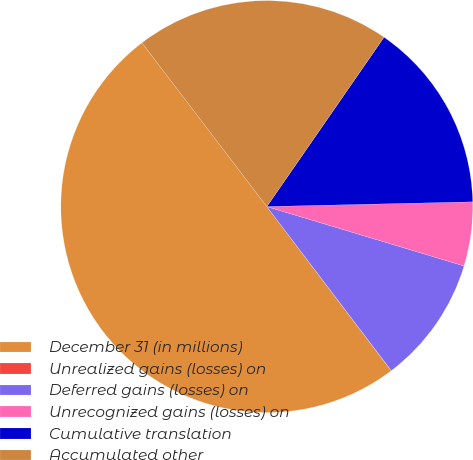Convert chart to OTSL. <chart><loc_0><loc_0><loc_500><loc_500><pie_chart><fcel>December 31 (in millions)<fcel>Unrealized gains (losses) on<fcel>Deferred gains (losses) on<fcel>Unrecognized gains (losses) on<fcel>Cumulative translation<fcel>Accumulated other<nl><fcel>49.95%<fcel>0.02%<fcel>10.01%<fcel>5.02%<fcel>15.0%<fcel>20.0%<nl></chart> 